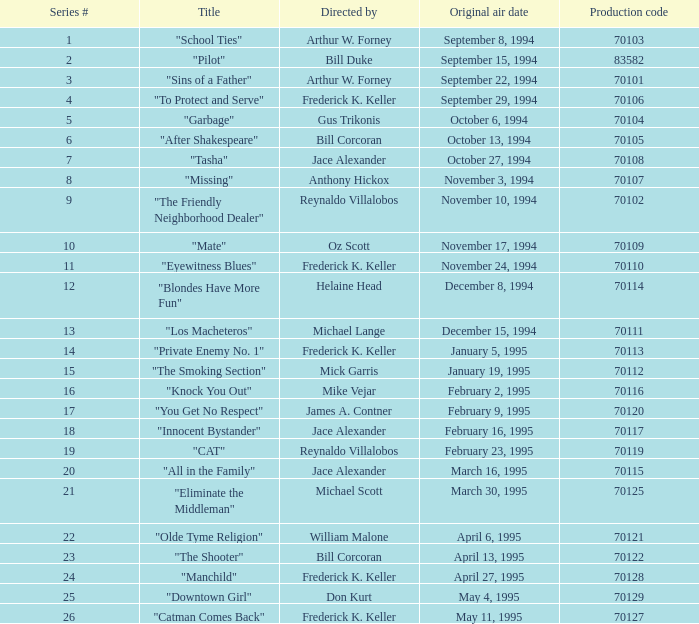Write the full table. {'header': ['Series #', 'Title', 'Directed by', 'Original air date', 'Production code'], 'rows': [['1', '"School Ties"', 'Arthur W. Forney', 'September 8, 1994', '70103'], ['2', '"Pilot"', 'Bill Duke', 'September 15, 1994', '83582'], ['3', '"Sins of a Father"', 'Arthur W. Forney', 'September 22, 1994', '70101'], ['4', '"To Protect and Serve"', 'Frederick K. Keller', 'September 29, 1994', '70106'], ['5', '"Garbage"', 'Gus Trikonis', 'October 6, 1994', '70104'], ['6', '"After Shakespeare"', 'Bill Corcoran', 'October 13, 1994', '70105'], ['7', '"Tasha"', 'Jace Alexander', 'October 27, 1994', '70108'], ['8', '"Missing"', 'Anthony Hickox', 'November 3, 1994', '70107'], ['9', '"The Friendly Neighborhood Dealer"', 'Reynaldo Villalobos', 'November 10, 1994', '70102'], ['10', '"Mate"', 'Oz Scott', 'November 17, 1994', '70109'], ['11', '"Eyewitness Blues"', 'Frederick K. Keller', 'November 24, 1994', '70110'], ['12', '"Blondes Have More Fun"', 'Helaine Head', 'December 8, 1994', '70114'], ['13', '"Los Macheteros"', 'Michael Lange', 'December 15, 1994', '70111'], ['14', '"Private Enemy No. 1"', 'Frederick K. Keller', 'January 5, 1995', '70113'], ['15', '"The Smoking Section"', 'Mick Garris', 'January 19, 1995', '70112'], ['16', '"Knock You Out"', 'Mike Vejar', 'February 2, 1995', '70116'], ['17', '"You Get No Respect"', 'James A. Contner', 'February 9, 1995', '70120'], ['18', '"Innocent Bystander"', 'Jace Alexander', 'February 16, 1995', '70117'], ['19', '"CAT"', 'Reynaldo Villalobos', 'February 23, 1995', '70119'], ['20', '"All in the Family"', 'Jace Alexander', 'March 16, 1995', '70115'], ['21', '"Eliminate the Middleman"', 'Michael Scott', 'March 30, 1995', '70125'], ['22', '"Olde Tyme Religion"', 'William Malone', 'April 6, 1995', '70121'], ['23', '"The Shooter"', 'Bill Corcoran', 'April 13, 1995', '70122'], ['24', '"Manchild"', 'Frederick K. Keller', 'April 27, 1995', '70128'], ['25', '"Downtown Girl"', 'Don Kurt', 'May 4, 1995', '70129'], ['26', '"Catman Comes Back"', 'Frederick K. Keller', 'May 11, 1995', '70127']]} What was the least production code value in series #10? 70109.0. 